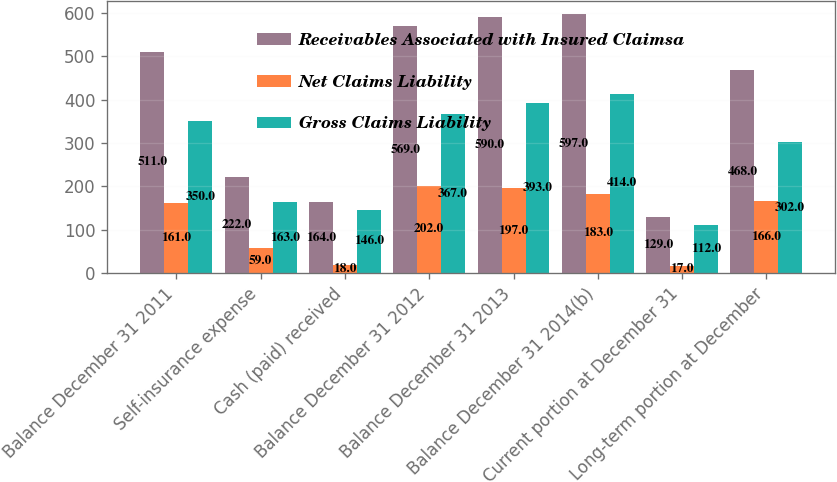<chart> <loc_0><loc_0><loc_500><loc_500><stacked_bar_chart><ecel><fcel>Balance December 31 2011<fcel>Self-insurance expense<fcel>Cash (paid) received<fcel>Balance December 31 2012<fcel>Balance December 31 2013<fcel>Balance December 31 2014(b)<fcel>Current portion at December 31<fcel>Long-term portion at December<nl><fcel>Receivables Associated with Insured Claimsa<fcel>511<fcel>222<fcel>164<fcel>569<fcel>590<fcel>597<fcel>129<fcel>468<nl><fcel>Net Claims Liability<fcel>161<fcel>59<fcel>18<fcel>202<fcel>197<fcel>183<fcel>17<fcel>166<nl><fcel>Gross Claims Liability<fcel>350<fcel>163<fcel>146<fcel>367<fcel>393<fcel>414<fcel>112<fcel>302<nl></chart> 